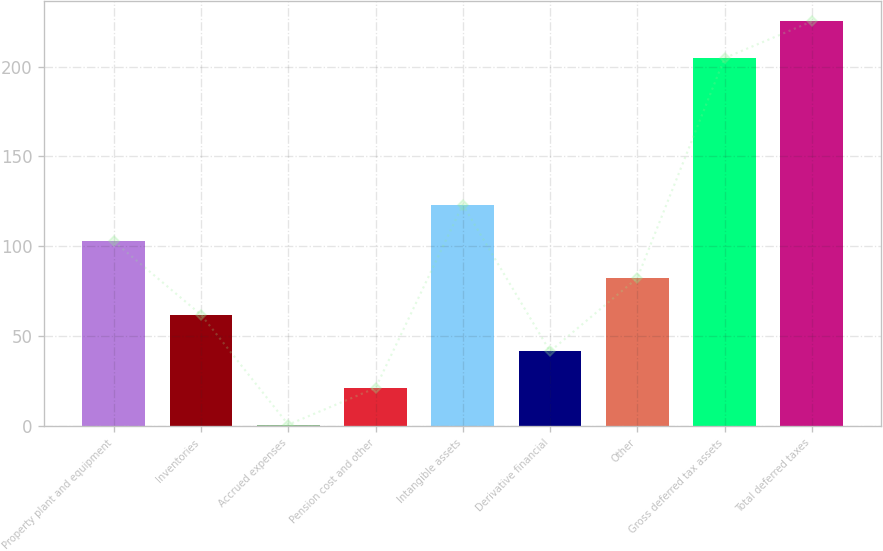<chart> <loc_0><loc_0><loc_500><loc_500><bar_chart><fcel>Property plant and equipment<fcel>Inventories<fcel>Accrued expenses<fcel>Pension cost and other<fcel>Intangible assets<fcel>Derivative financial<fcel>Other<fcel>Gross deferred tax assets<fcel>Total deferred taxes<nl><fcel>102.75<fcel>61.97<fcel>0.8<fcel>21.19<fcel>123.14<fcel>41.58<fcel>82.36<fcel>204.7<fcel>225.09<nl></chart> 